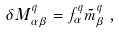<formula> <loc_0><loc_0><loc_500><loc_500>\delta M ^ { q } _ { \alpha \beta } = f ^ { q } _ { \alpha } \tilde { m } ^ { q } _ { \beta } \, ,</formula> 